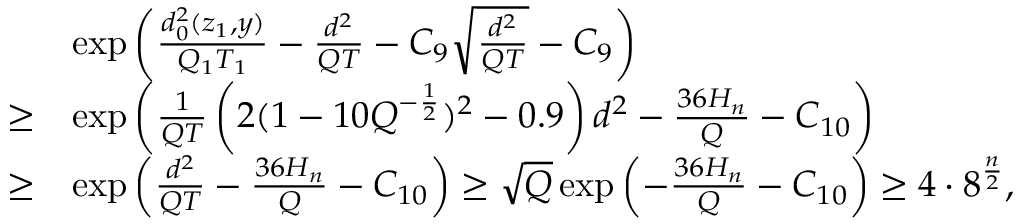Convert formula to latex. <formula><loc_0><loc_0><loc_500><loc_500>\begin{array} { r l } & { \exp \left ( \frac { d _ { 0 } ^ { 2 } ( z _ { 1 } , y ) } { Q _ { 1 } T _ { 1 } } - \frac { d ^ { 2 } } { Q T } - C _ { 9 } \sqrt { \frac { d ^ { 2 } } { Q T } } - C _ { 9 } \right ) } \\ { \geq } & { \exp \left ( \frac { 1 } { Q T } \left ( 2 ( 1 - 1 0 Q ^ { - \frac { 1 } { 2 } } ) ^ { 2 } - 0 . 9 \right ) d ^ { 2 } - \frac { 3 6 H _ { n } } { Q } - C _ { 1 0 } \right ) } \\ { \geq } & { \exp \left ( \frac { d ^ { 2 } } { Q T } - \frac { 3 6 H _ { n } } { Q } - C _ { 1 0 } \right ) \geq \sqrt { Q } \exp \left ( - \frac { 3 6 H _ { n } } { Q } - C _ { 1 0 } \right ) \geq 4 \cdot 8 ^ { \frac { n } { 2 } } , } \end{array}</formula> 